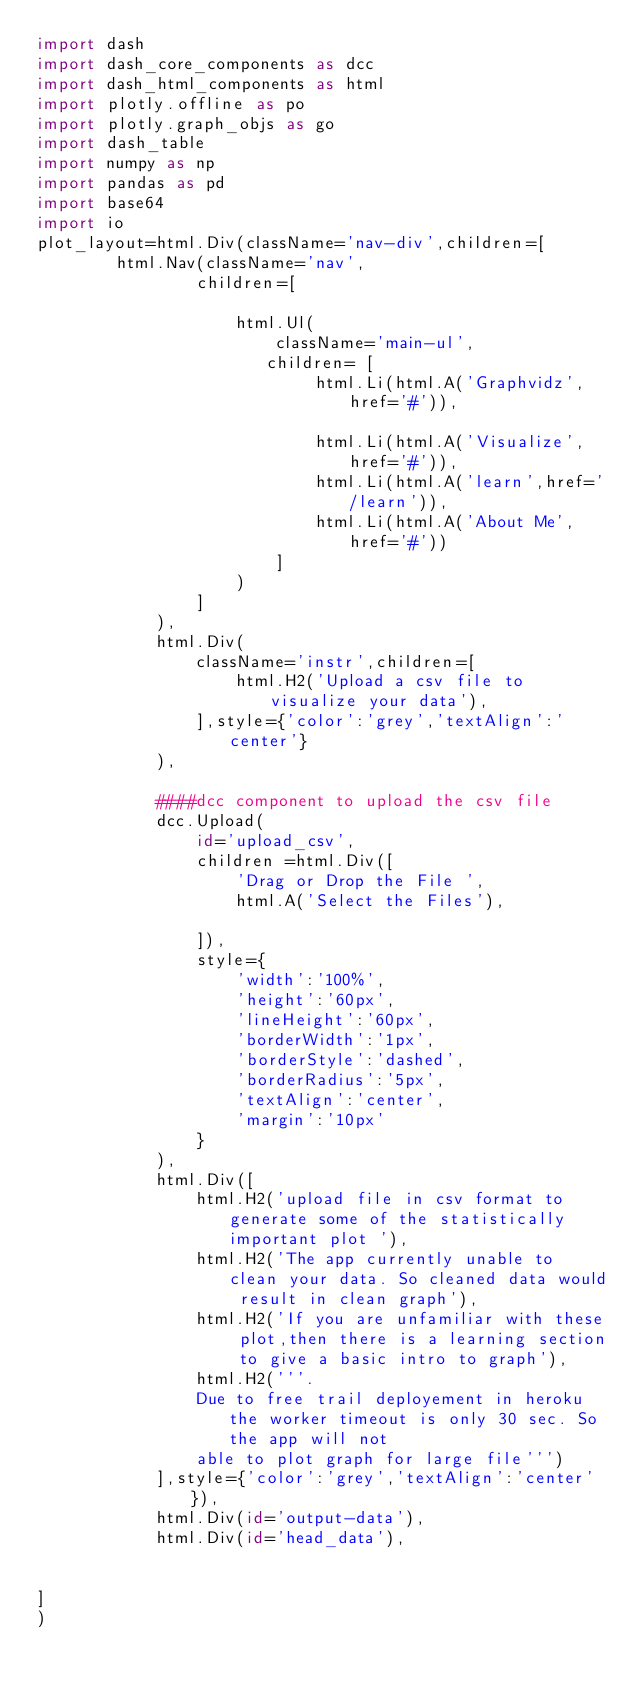Convert code to text. <code><loc_0><loc_0><loc_500><loc_500><_Python_>import dash
import dash_core_components as dcc
import dash_html_components as html
import plotly.offline as po 
import plotly.graph_objs as go
import dash_table
import numpy as np 
import pandas as pd 
import base64
import io
plot_layout=html.Div(className='nav-div',children=[
				html.Nav(className='nav',
                children=[
                    
                    html.Ul(
                        className='main-ul',
                       children= [
                            html.Li(html.A('Graphvidz',href='#')),
                            
                            html.Li(html.A('Visualize',href='#')),
                            html.Li(html.A('learn',href='/learn')),
                            html.Li(html.A('About Me',href='#'))
                        ]
                    )
                ]
            ),
            html.Div(
                className='instr',children=[
                    html.H2('Upload a csv file to visualize your data'),
                ],style={'color':'grey','textAlign':'center'}
            ),

            ####dcc component to upload the csv file 
            dcc.Upload(
                id='upload_csv',
                children =html.Div([
                    'Drag or Drop the File ',
                    html.A('Select the Files'),

                ]),
                style={
                    'width':'100%',
                    'height':'60px',
                    'lineHeight':'60px',
                    'borderWidth':'1px',
                    'borderStyle':'dashed',
                    'borderRadius':'5px',
                    'textAlign':'center',
                    'margin':'10px'
                }
            ),
            html.Div([
                html.H2('upload file in csv format to generate some of the statistically important plot '),
                html.H2('The app currently unable to clean your data. So cleaned data would result in clean graph'),
                html.H2('If you are unfamiliar with these plot,then there is a learning section to give a basic intro to graph'),
                html.H2('''.
                Due to free trail deployement in heroku the worker timeout is only 30 sec. So the app will not 
                able to plot graph for large file''')
            ],style={'color':'grey','textAlign':'center'}),
            html.Div(id='output-data'),
            html.Div(id='head_data'),
           

]
)



</code> 